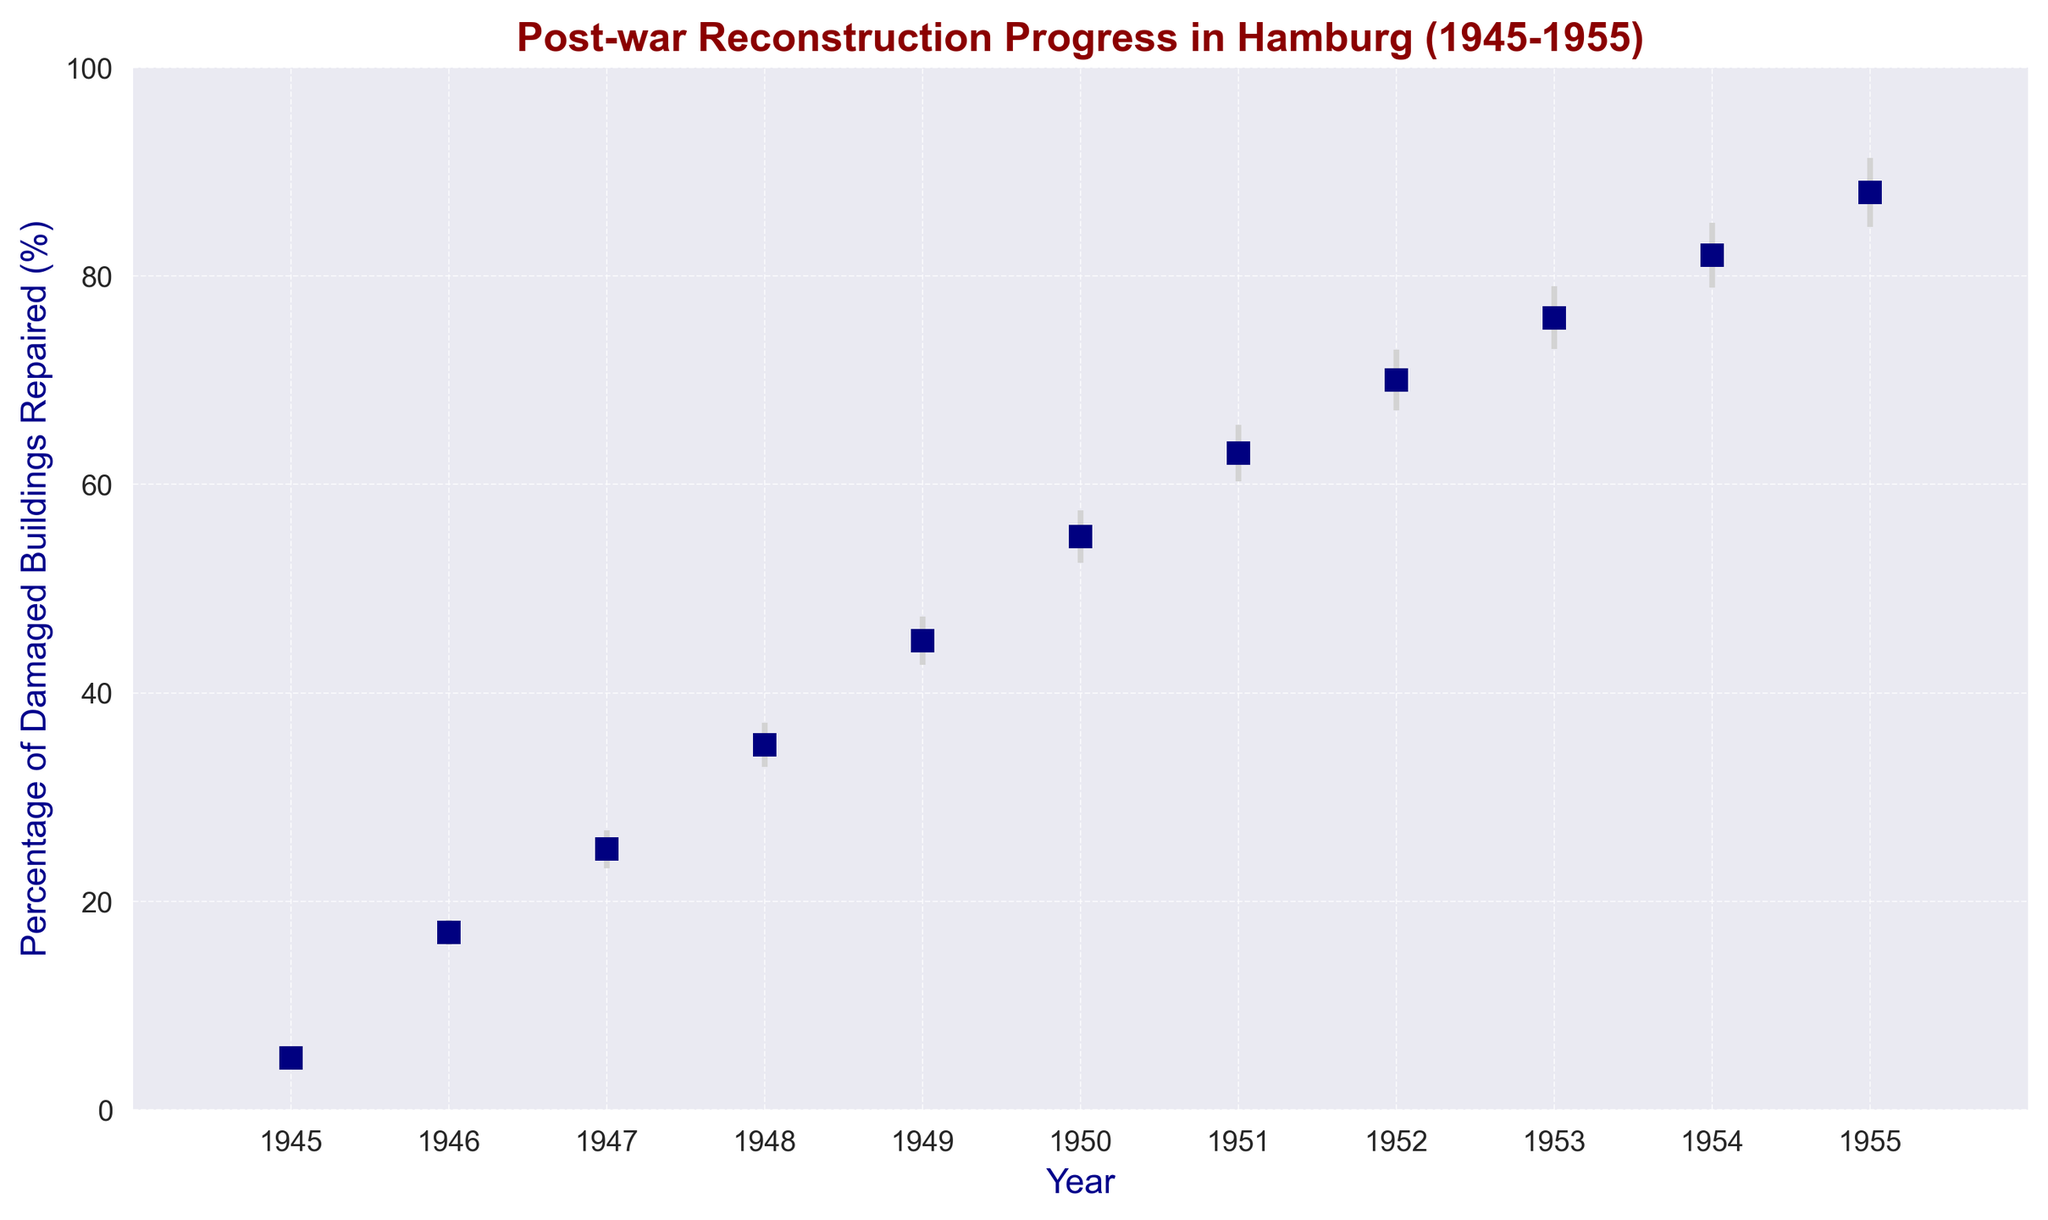What is the percentage increase in repaired buildings from 1945 to 1950? In 1945, about 5% of the buildings were repaired. By 1950, this was about 55%. The increase is 55% - 5% = 50%
Answer: 50% In which year did the percentage of repaired buildings surpass 50%? Referring to the x-axis and the y-axis, the percentage of repaired buildings first surpassed 50% in the year 1950.
Answer: 1950 What is the difference in the percentages of repaired buildings between 1947 and 1955? The percentage in 1947 is 25%, and in 1955, it is 88%. The difference is 88% - 25% = 63%
Answer: 63% When was the reconstruction progress the slowest, based on the error bars? The error bars are widest in 1945, indicating more uncertainty. Therefore, the slowest progress, which is hard to estimate with confidence, appears to be around 1945.
Answer: 1945 What is the modeled error range for the percentage of buildings repaired in 1952? In 1952, the percentage repaired is 70%, and the standard error is 2.9%. Therefore, the range is 70% ± 2.9%, which is from 67.1% to 72.9%.
Answer: 67.1% to 72.9% What is the average percentage of buildings repaired for the years 1945 and 1946? In 1945, the percentage is 5%, and in 1946, it is 17%. The average is (5% + 17%) / 2 = 11%
Answer: 11% In which year did the percentage of repaired buildings increase the most compared to the previous year? Comparing adjacent years, the largest increase happens from 1945 (5%) to 1946 (17%), which is an increase of 12%.
Answer: 1946 Which year shows the least uncertainty in the reconstruction progress, considering the error bars? The year 1945 has the smallest error bar, indicating the least uncertainty.
Answer: 1945 By how much did the percentage of repaired buildings increase from 1948 to 1949? In 1948, the percentage is 35%, and in 1949, it is 45%. The increase is 45% - 35% = 10%
Answer: 10% What is the cumulative percentage of repaired buildings by 1951? Add the yearly percentages up to and including 1951: 5%+17%+25%+35%+45%+55%+63% = 245%. However, this is not meant as a cumulative percentage in the usual sense, but rather the stated percentage for each year.
Answer: 63% 